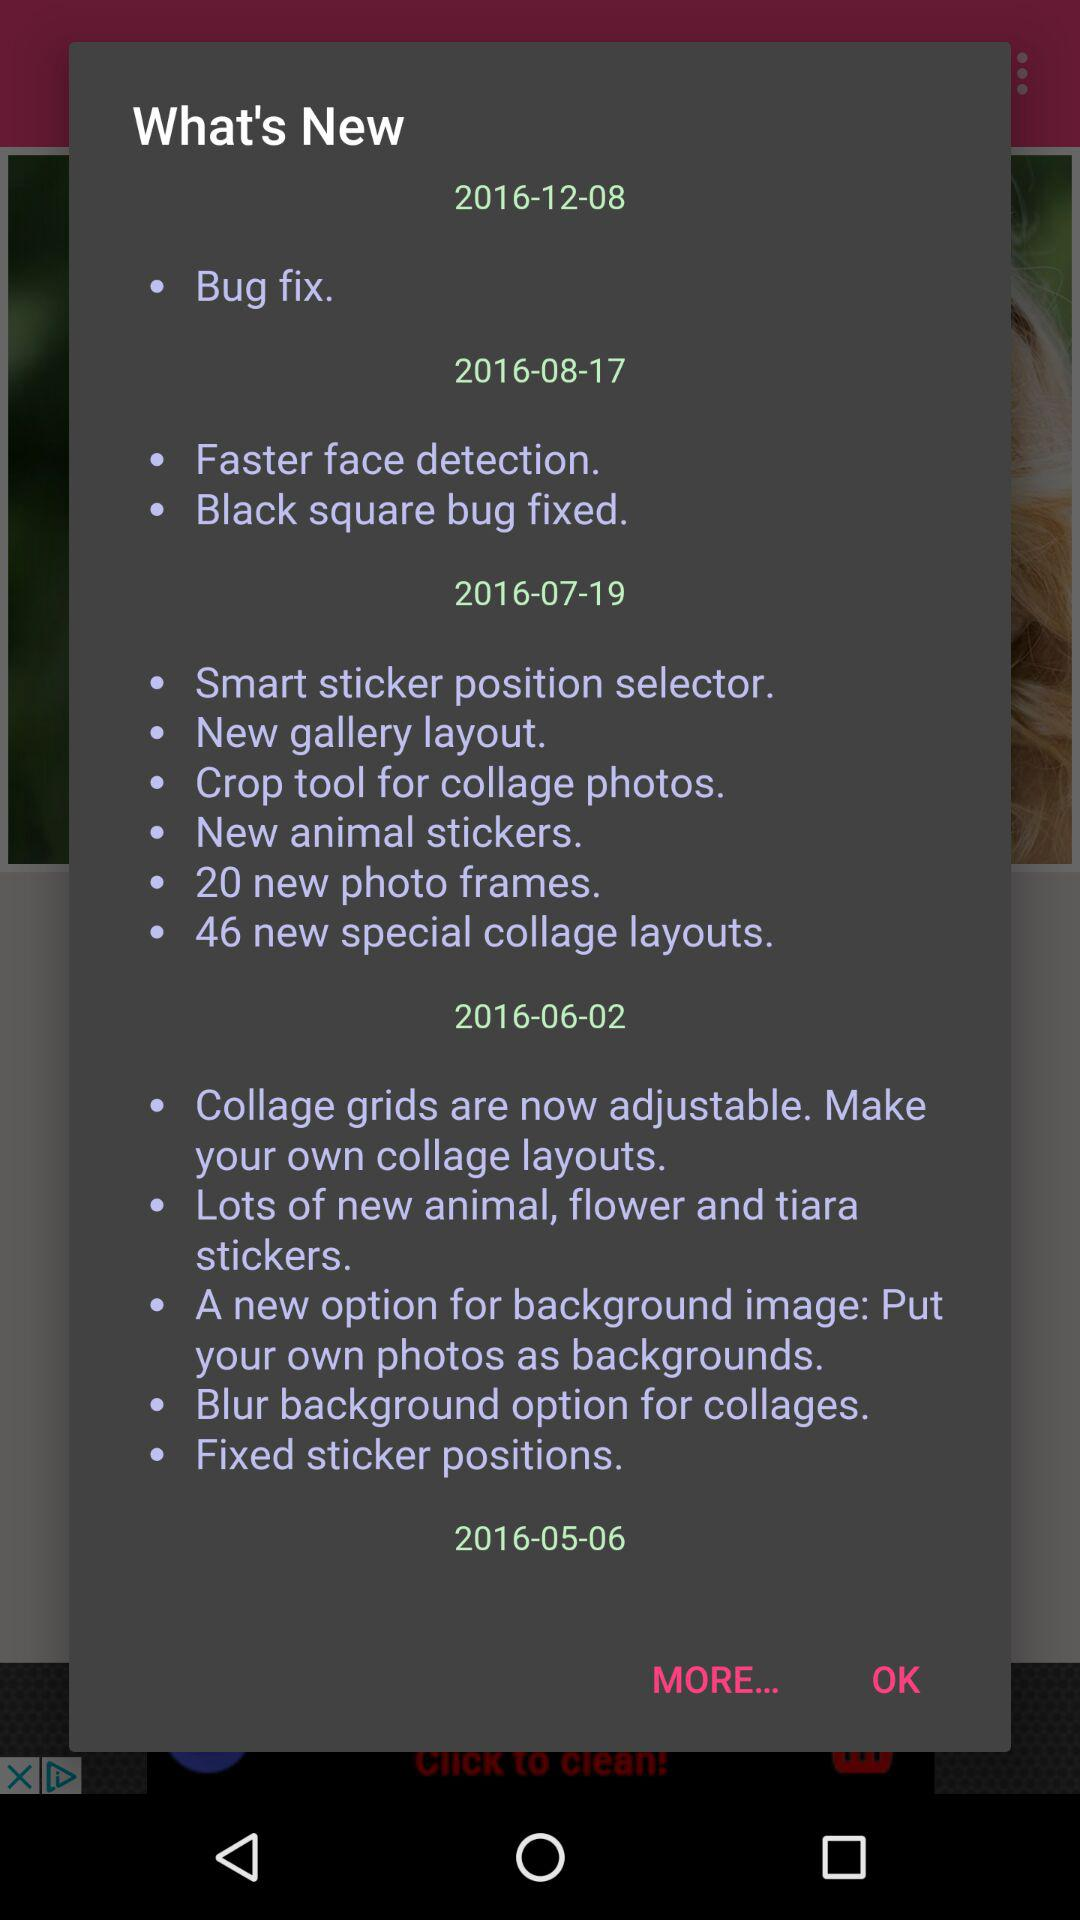What's new in 2016-12-08? The new in 2016-12-08 is "Bug fix". 